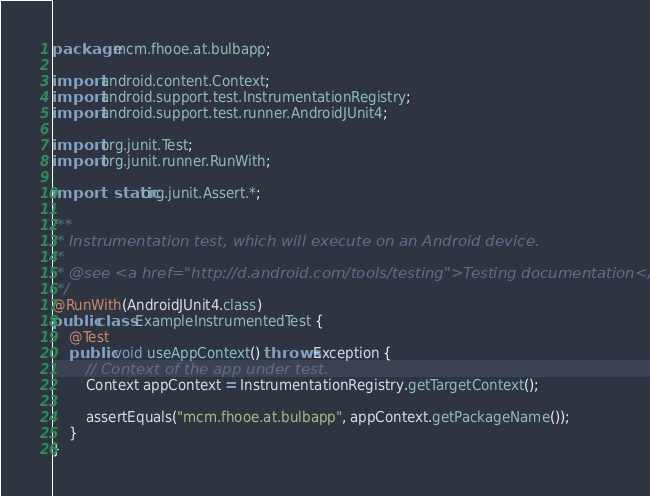Convert code to text. <code><loc_0><loc_0><loc_500><loc_500><_Java_>package mcm.fhooe.at.bulbapp;

import android.content.Context;
import android.support.test.InstrumentationRegistry;
import android.support.test.runner.AndroidJUnit4;

import org.junit.Test;
import org.junit.runner.RunWith;

import static org.junit.Assert.*;

/**
 * Instrumentation test, which will execute on an Android device.
 *
 * @see <a href="http://d.android.com/tools/testing">Testing documentation</a>
 */
@RunWith(AndroidJUnit4.class)
public class ExampleInstrumentedTest {
    @Test
    public void useAppContext() throws Exception {
        // Context of the app under test.
        Context appContext = InstrumentationRegistry.getTargetContext();

        assertEquals("mcm.fhooe.at.bulbapp", appContext.getPackageName());
    }
}
</code> 